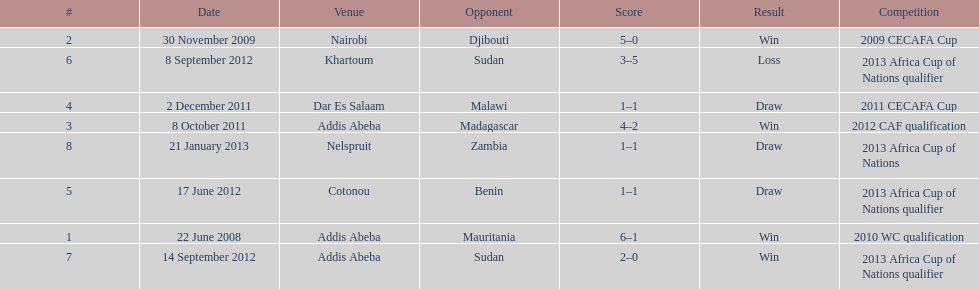How long in years down this table cover? 5. 